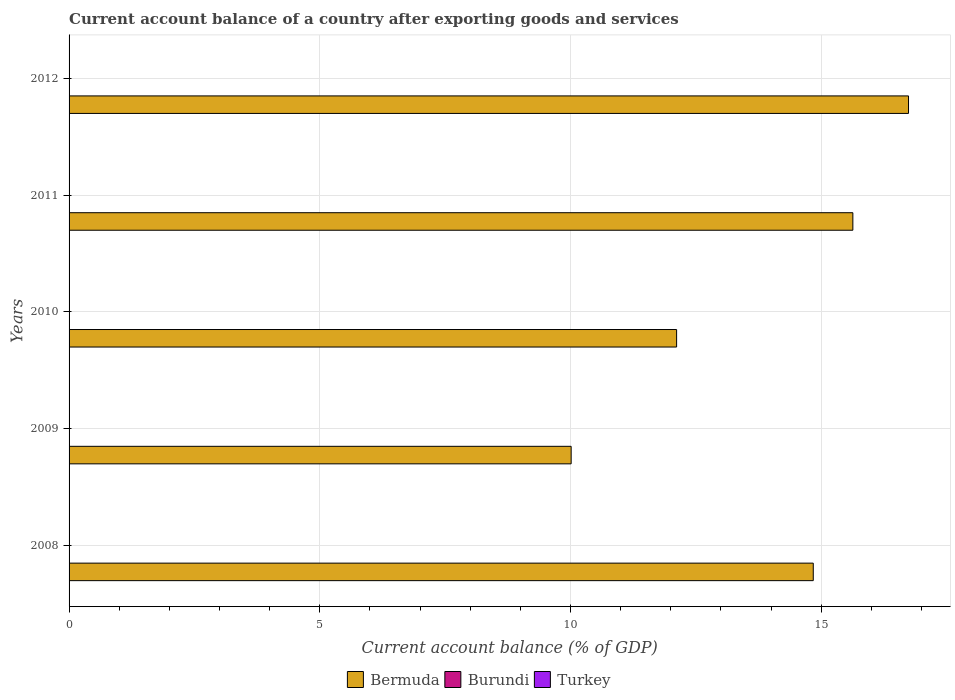How many different coloured bars are there?
Give a very brief answer. 1. How many bars are there on the 3rd tick from the top?
Ensure brevity in your answer.  1. What is the account balance in Bermuda in 2011?
Provide a succinct answer. 15.63. Across all years, what is the maximum account balance in Bermuda?
Provide a succinct answer. 16.74. What is the difference between the account balance in Bermuda in 2009 and that in 2010?
Provide a succinct answer. -2.1. Is the account balance in Bermuda in 2010 less than that in 2011?
Offer a very short reply. Yes. What is the difference between the highest and the second highest account balance in Bermuda?
Provide a short and direct response. 1.11. What is the difference between the highest and the lowest account balance in Bermuda?
Provide a short and direct response. 6.73. Are all the bars in the graph horizontal?
Keep it short and to the point. Yes. How many years are there in the graph?
Offer a terse response. 5. How many legend labels are there?
Give a very brief answer. 3. How are the legend labels stacked?
Offer a very short reply. Horizontal. What is the title of the graph?
Give a very brief answer. Current account balance of a country after exporting goods and services. Does "Tajikistan" appear as one of the legend labels in the graph?
Provide a succinct answer. No. What is the label or title of the X-axis?
Keep it short and to the point. Current account balance (% of GDP). What is the label or title of the Y-axis?
Your answer should be compact. Years. What is the Current account balance (% of GDP) of Bermuda in 2008?
Ensure brevity in your answer.  14.84. What is the Current account balance (% of GDP) in Burundi in 2008?
Keep it short and to the point. 0. What is the Current account balance (% of GDP) of Turkey in 2008?
Your answer should be very brief. 0. What is the Current account balance (% of GDP) in Bermuda in 2009?
Offer a terse response. 10.01. What is the Current account balance (% of GDP) of Burundi in 2009?
Ensure brevity in your answer.  0. What is the Current account balance (% of GDP) in Bermuda in 2010?
Give a very brief answer. 12.12. What is the Current account balance (% of GDP) of Burundi in 2010?
Ensure brevity in your answer.  0. What is the Current account balance (% of GDP) of Bermuda in 2011?
Keep it short and to the point. 15.63. What is the Current account balance (% of GDP) in Burundi in 2011?
Make the answer very short. 0. What is the Current account balance (% of GDP) in Bermuda in 2012?
Your response must be concise. 16.74. What is the Current account balance (% of GDP) in Burundi in 2012?
Your response must be concise. 0. Across all years, what is the maximum Current account balance (% of GDP) in Bermuda?
Provide a short and direct response. 16.74. Across all years, what is the minimum Current account balance (% of GDP) of Bermuda?
Make the answer very short. 10.01. What is the total Current account balance (% of GDP) in Bermuda in the graph?
Provide a succinct answer. 69.34. What is the difference between the Current account balance (% of GDP) in Bermuda in 2008 and that in 2009?
Your answer should be compact. 4.83. What is the difference between the Current account balance (% of GDP) of Bermuda in 2008 and that in 2010?
Offer a terse response. 2.73. What is the difference between the Current account balance (% of GDP) of Bermuda in 2008 and that in 2011?
Your response must be concise. -0.79. What is the difference between the Current account balance (% of GDP) of Bermuda in 2008 and that in 2012?
Offer a very short reply. -1.9. What is the difference between the Current account balance (% of GDP) in Bermuda in 2009 and that in 2010?
Keep it short and to the point. -2.1. What is the difference between the Current account balance (% of GDP) in Bermuda in 2009 and that in 2011?
Give a very brief answer. -5.62. What is the difference between the Current account balance (% of GDP) of Bermuda in 2009 and that in 2012?
Provide a succinct answer. -6.73. What is the difference between the Current account balance (% of GDP) in Bermuda in 2010 and that in 2011?
Provide a succinct answer. -3.51. What is the difference between the Current account balance (% of GDP) of Bermuda in 2010 and that in 2012?
Keep it short and to the point. -4.62. What is the difference between the Current account balance (% of GDP) in Bermuda in 2011 and that in 2012?
Make the answer very short. -1.11. What is the average Current account balance (% of GDP) in Bermuda per year?
Provide a short and direct response. 13.87. What is the average Current account balance (% of GDP) in Burundi per year?
Ensure brevity in your answer.  0. What is the ratio of the Current account balance (% of GDP) in Bermuda in 2008 to that in 2009?
Make the answer very short. 1.48. What is the ratio of the Current account balance (% of GDP) in Bermuda in 2008 to that in 2010?
Provide a short and direct response. 1.22. What is the ratio of the Current account balance (% of GDP) in Bermuda in 2008 to that in 2011?
Your answer should be very brief. 0.95. What is the ratio of the Current account balance (% of GDP) of Bermuda in 2008 to that in 2012?
Offer a terse response. 0.89. What is the ratio of the Current account balance (% of GDP) of Bermuda in 2009 to that in 2010?
Offer a very short reply. 0.83. What is the ratio of the Current account balance (% of GDP) in Bermuda in 2009 to that in 2011?
Keep it short and to the point. 0.64. What is the ratio of the Current account balance (% of GDP) of Bermuda in 2009 to that in 2012?
Your response must be concise. 0.6. What is the ratio of the Current account balance (% of GDP) of Bermuda in 2010 to that in 2011?
Offer a very short reply. 0.78. What is the ratio of the Current account balance (% of GDP) of Bermuda in 2010 to that in 2012?
Offer a terse response. 0.72. What is the ratio of the Current account balance (% of GDP) in Bermuda in 2011 to that in 2012?
Provide a short and direct response. 0.93. What is the difference between the highest and the second highest Current account balance (% of GDP) in Bermuda?
Offer a very short reply. 1.11. What is the difference between the highest and the lowest Current account balance (% of GDP) in Bermuda?
Give a very brief answer. 6.73. 